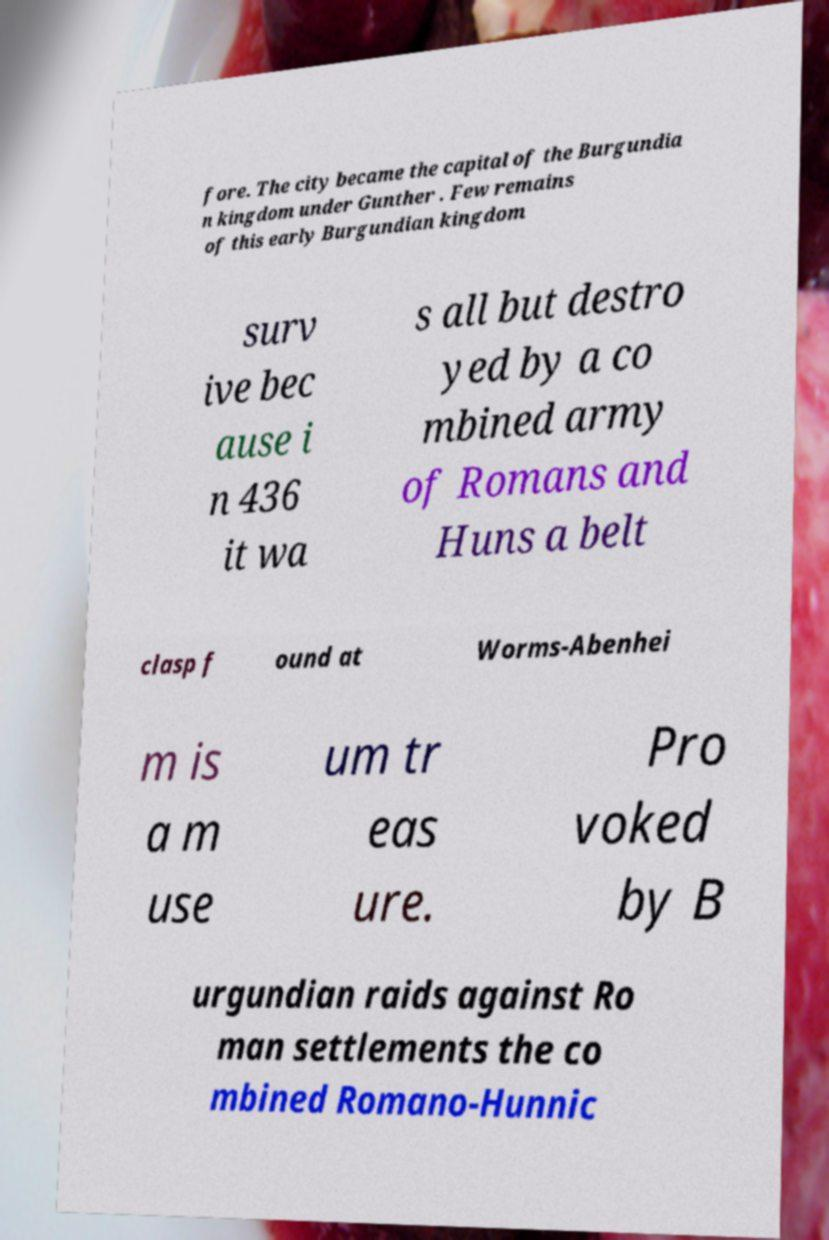Can you read and provide the text displayed in the image?This photo seems to have some interesting text. Can you extract and type it out for me? fore. The city became the capital of the Burgundia n kingdom under Gunther . Few remains of this early Burgundian kingdom surv ive bec ause i n 436 it wa s all but destro yed by a co mbined army of Romans and Huns a belt clasp f ound at Worms-Abenhei m is a m use um tr eas ure. Pro voked by B urgundian raids against Ro man settlements the co mbined Romano-Hunnic 